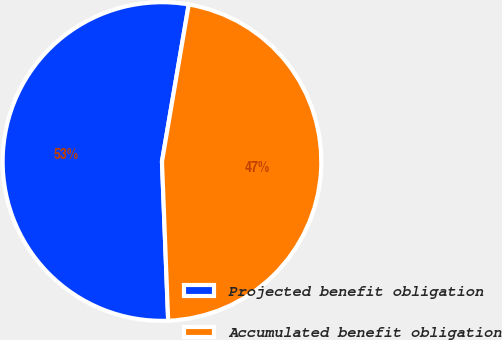Convert chart to OTSL. <chart><loc_0><loc_0><loc_500><loc_500><pie_chart><fcel>Projected benefit obligation<fcel>Accumulated benefit obligation<nl><fcel>53.31%<fcel>46.69%<nl></chart> 